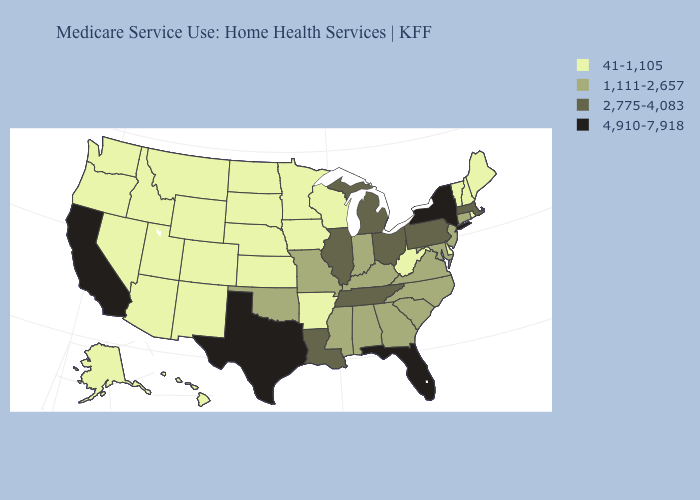Which states hav the highest value in the MidWest?
Keep it brief. Illinois, Michigan, Ohio. Does Colorado have the highest value in the West?
Be succinct. No. What is the value of New Hampshire?
Quick response, please. 41-1,105. Name the states that have a value in the range 41-1,105?
Quick response, please. Alaska, Arizona, Arkansas, Colorado, Delaware, Hawaii, Idaho, Iowa, Kansas, Maine, Minnesota, Montana, Nebraska, Nevada, New Hampshire, New Mexico, North Dakota, Oregon, Rhode Island, South Dakota, Utah, Vermont, Washington, West Virginia, Wisconsin, Wyoming. Is the legend a continuous bar?
Short answer required. No. Among the states that border Pennsylvania , which have the lowest value?
Give a very brief answer. Delaware, West Virginia. Which states hav the highest value in the West?
Keep it brief. California. Name the states that have a value in the range 1,111-2,657?
Concise answer only. Alabama, Connecticut, Georgia, Indiana, Kentucky, Maryland, Mississippi, Missouri, New Jersey, North Carolina, Oklahoma, South Carolina, Virginia. Does the first symbol in the legend represent the smallest category?
Concise answer only. Yes. What is the value of Virginia?
Short answer required. 1,111-2,657. Which states have the lowest value in the USA?
Give a very brief answer. Alaska, Arizona, Arkansas, Colorado, Delaware, Hawaii, Idaho, Iowa, Kansas, Maine, Minnesota, Montana, Nebraska, Nevada, New Hampshire, New Mexico, North Dakota, Oregon, Rhode Island, South Dakota, Utah, Vermont, Washington, West Virginia, Wisconsin, Wyoming. Among the states that border West Virginia , does Ohio have the lowest value?
Answer briefly. No. How many symbols are there in the legend?
Answer briefly. 4. What is the highest value in states that border North Carolina?
Concise answer only. 2,775-4,083. 